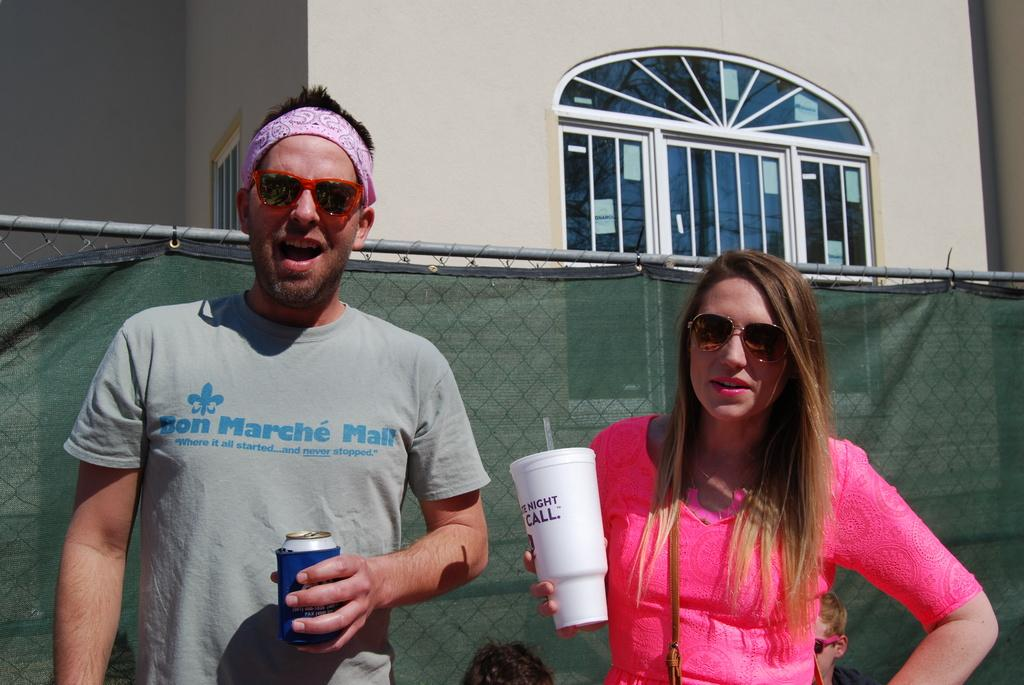How many people are present in the image? There is a man and a woman in the image. What are the man and woman holding in the image? The man and woman are holding beverage containers. What can be seen in the background of the image? There is a wall, windows, and mesh in the background of the image. What type of ornament is hanging from the man's pocket in the image? There is no ornament hanging from the man's pocket in the image, as there is no mention of a pocket or an ornament in the provided facts. 